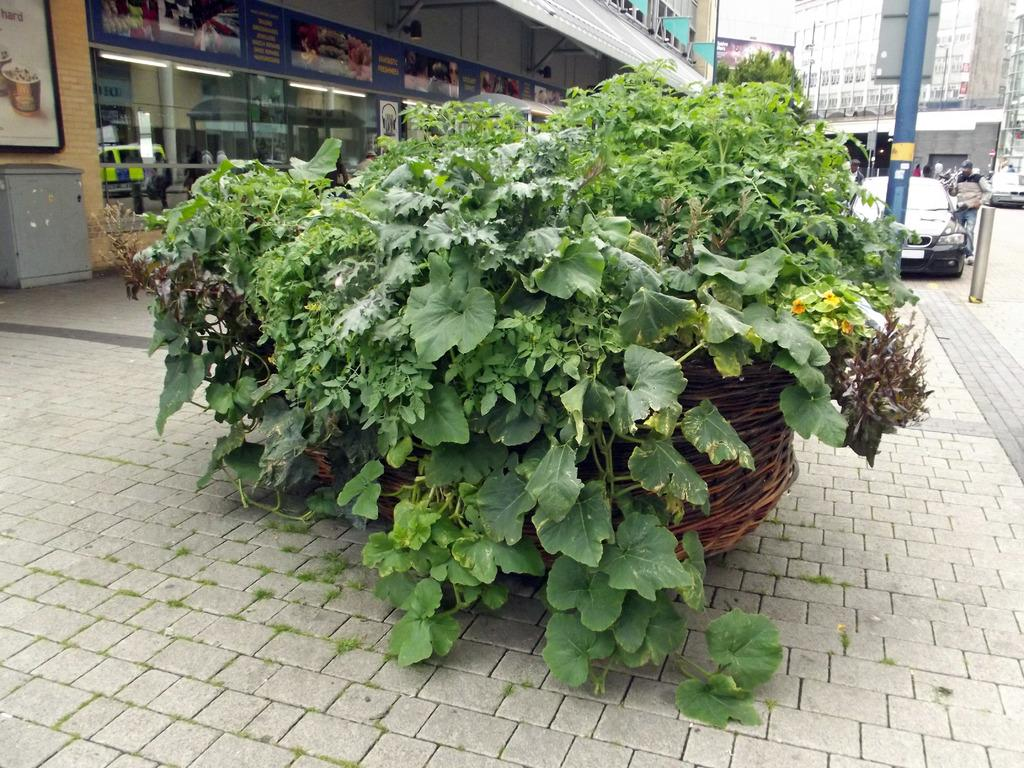What is located in the foreground of the image? There is a plant in the foreground of the image. What type of structures can be seen in the image? There are stalls, posters, vehicles, people, buildings, and poles in the image. What is visible in the background of the image? The sky is visible in the background of the image. What type of birthday celebration is taking place in the image? There is no indication of a birthday celebration in the image. What type of party can be seen in the image? There is no party visible in the image. 